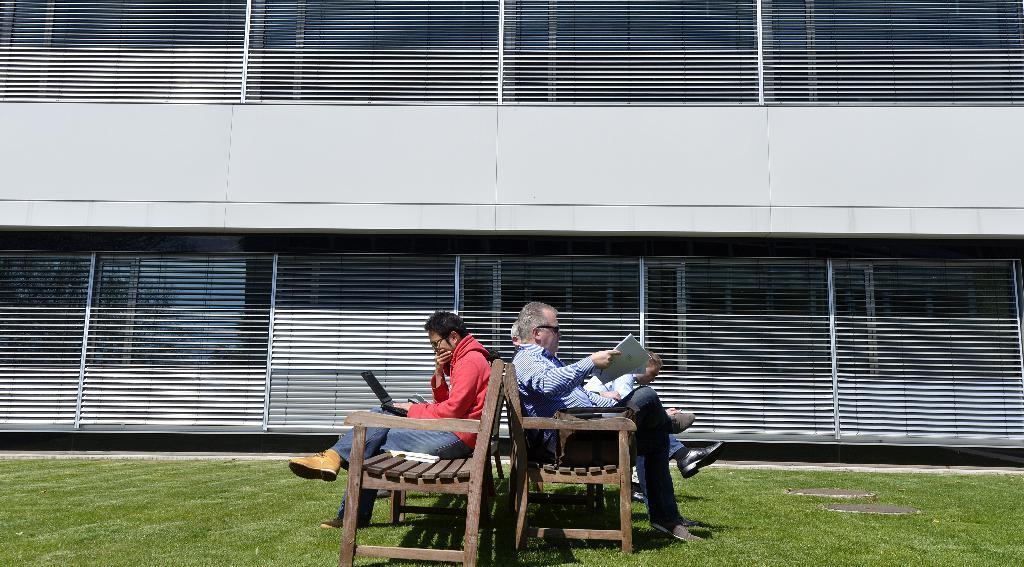Describe this image in one or two sentences. In the middle a man is sitting on this bench, he wore a red color coat. This side an old man is sitting on this and reading something. 